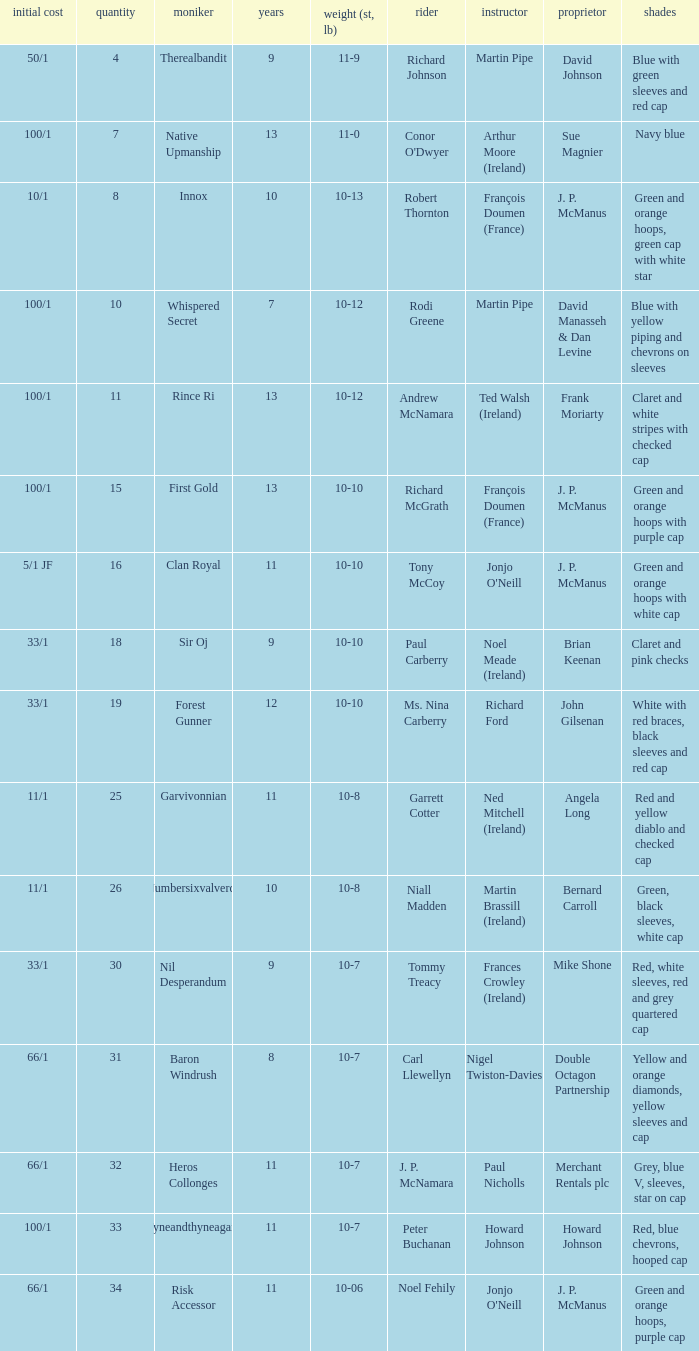How many age entries had a weight of 10-7 and an owner of Double Octagon Partnership? 1.0. 